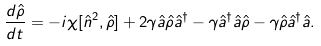Convert formula to latex. <formula><loc_0><loc_0><loc_500><loc_500>\frac { d \hat { \rho } } { d t } = - i \chi [ \hat { n } ^ { 2 } , \hat { \rho } ] + 2 \gamma \hat { a } \hat { \rho } \hat { a } ^ { \dagger } - \gamma \hat { a } ^ { \dagger } \hat { a } \hat { \rho } - \gamma \hat { \rho } \hat { a } ^ { \dagger } \hat { a } .</formula> 